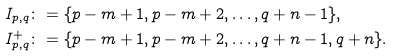<formula> <loc_0><loc_0><loc_500><loc_500>I _ { p , q } & \colon = \{ p - m + 1 , p - m + 2 , \dots , q + n - 1 \} , \\ I _ { p , q } ^ { + } & \colon = \{ p - m + 1 , p - m + 2 , \dots , q + n - 1 , q + n \} .</formula> 